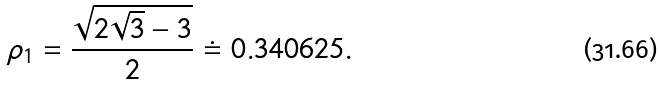Convert formula to latex. <formula><loc_0><loc_0><loc_500><loc_500>\rho _ { 1 } = \frac { \sqrt { 2 \sqrt { 3 } - 3 } } { 2 } \doteq 0 . 3 4 0 6 2 5 .</formula> 